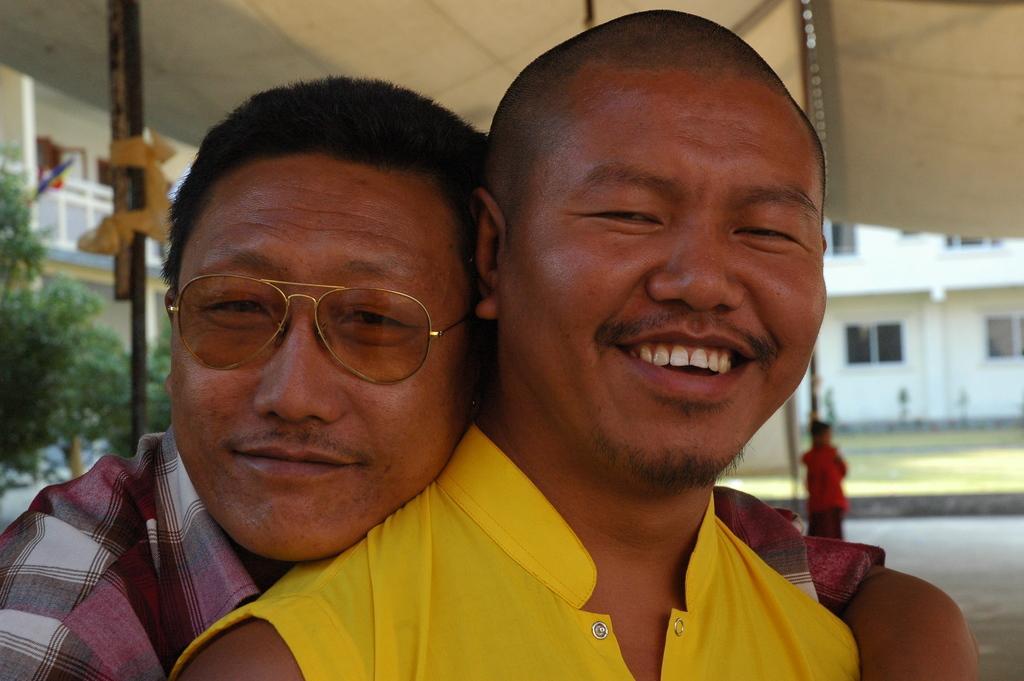Could you give a brief overview of what you see in this image? There are two persons. Person on the left is wearing a specs. In the background there is a building with windows. Also there are trees. 